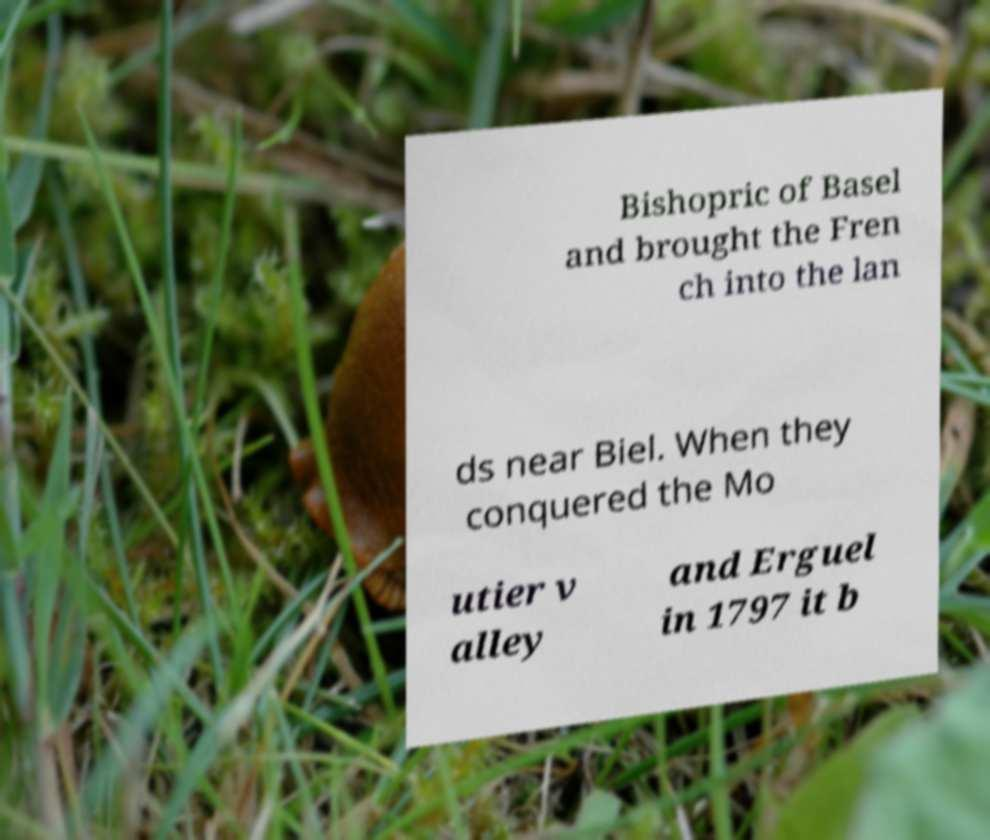There's text embedded in this image that I need extracted. Can you transcribe it verbatim? Bishopric of Basel and brought the Fren ch into the lan ds near Biel. When they conquered the Mo utier v alley and Erguel in 1797 it b 